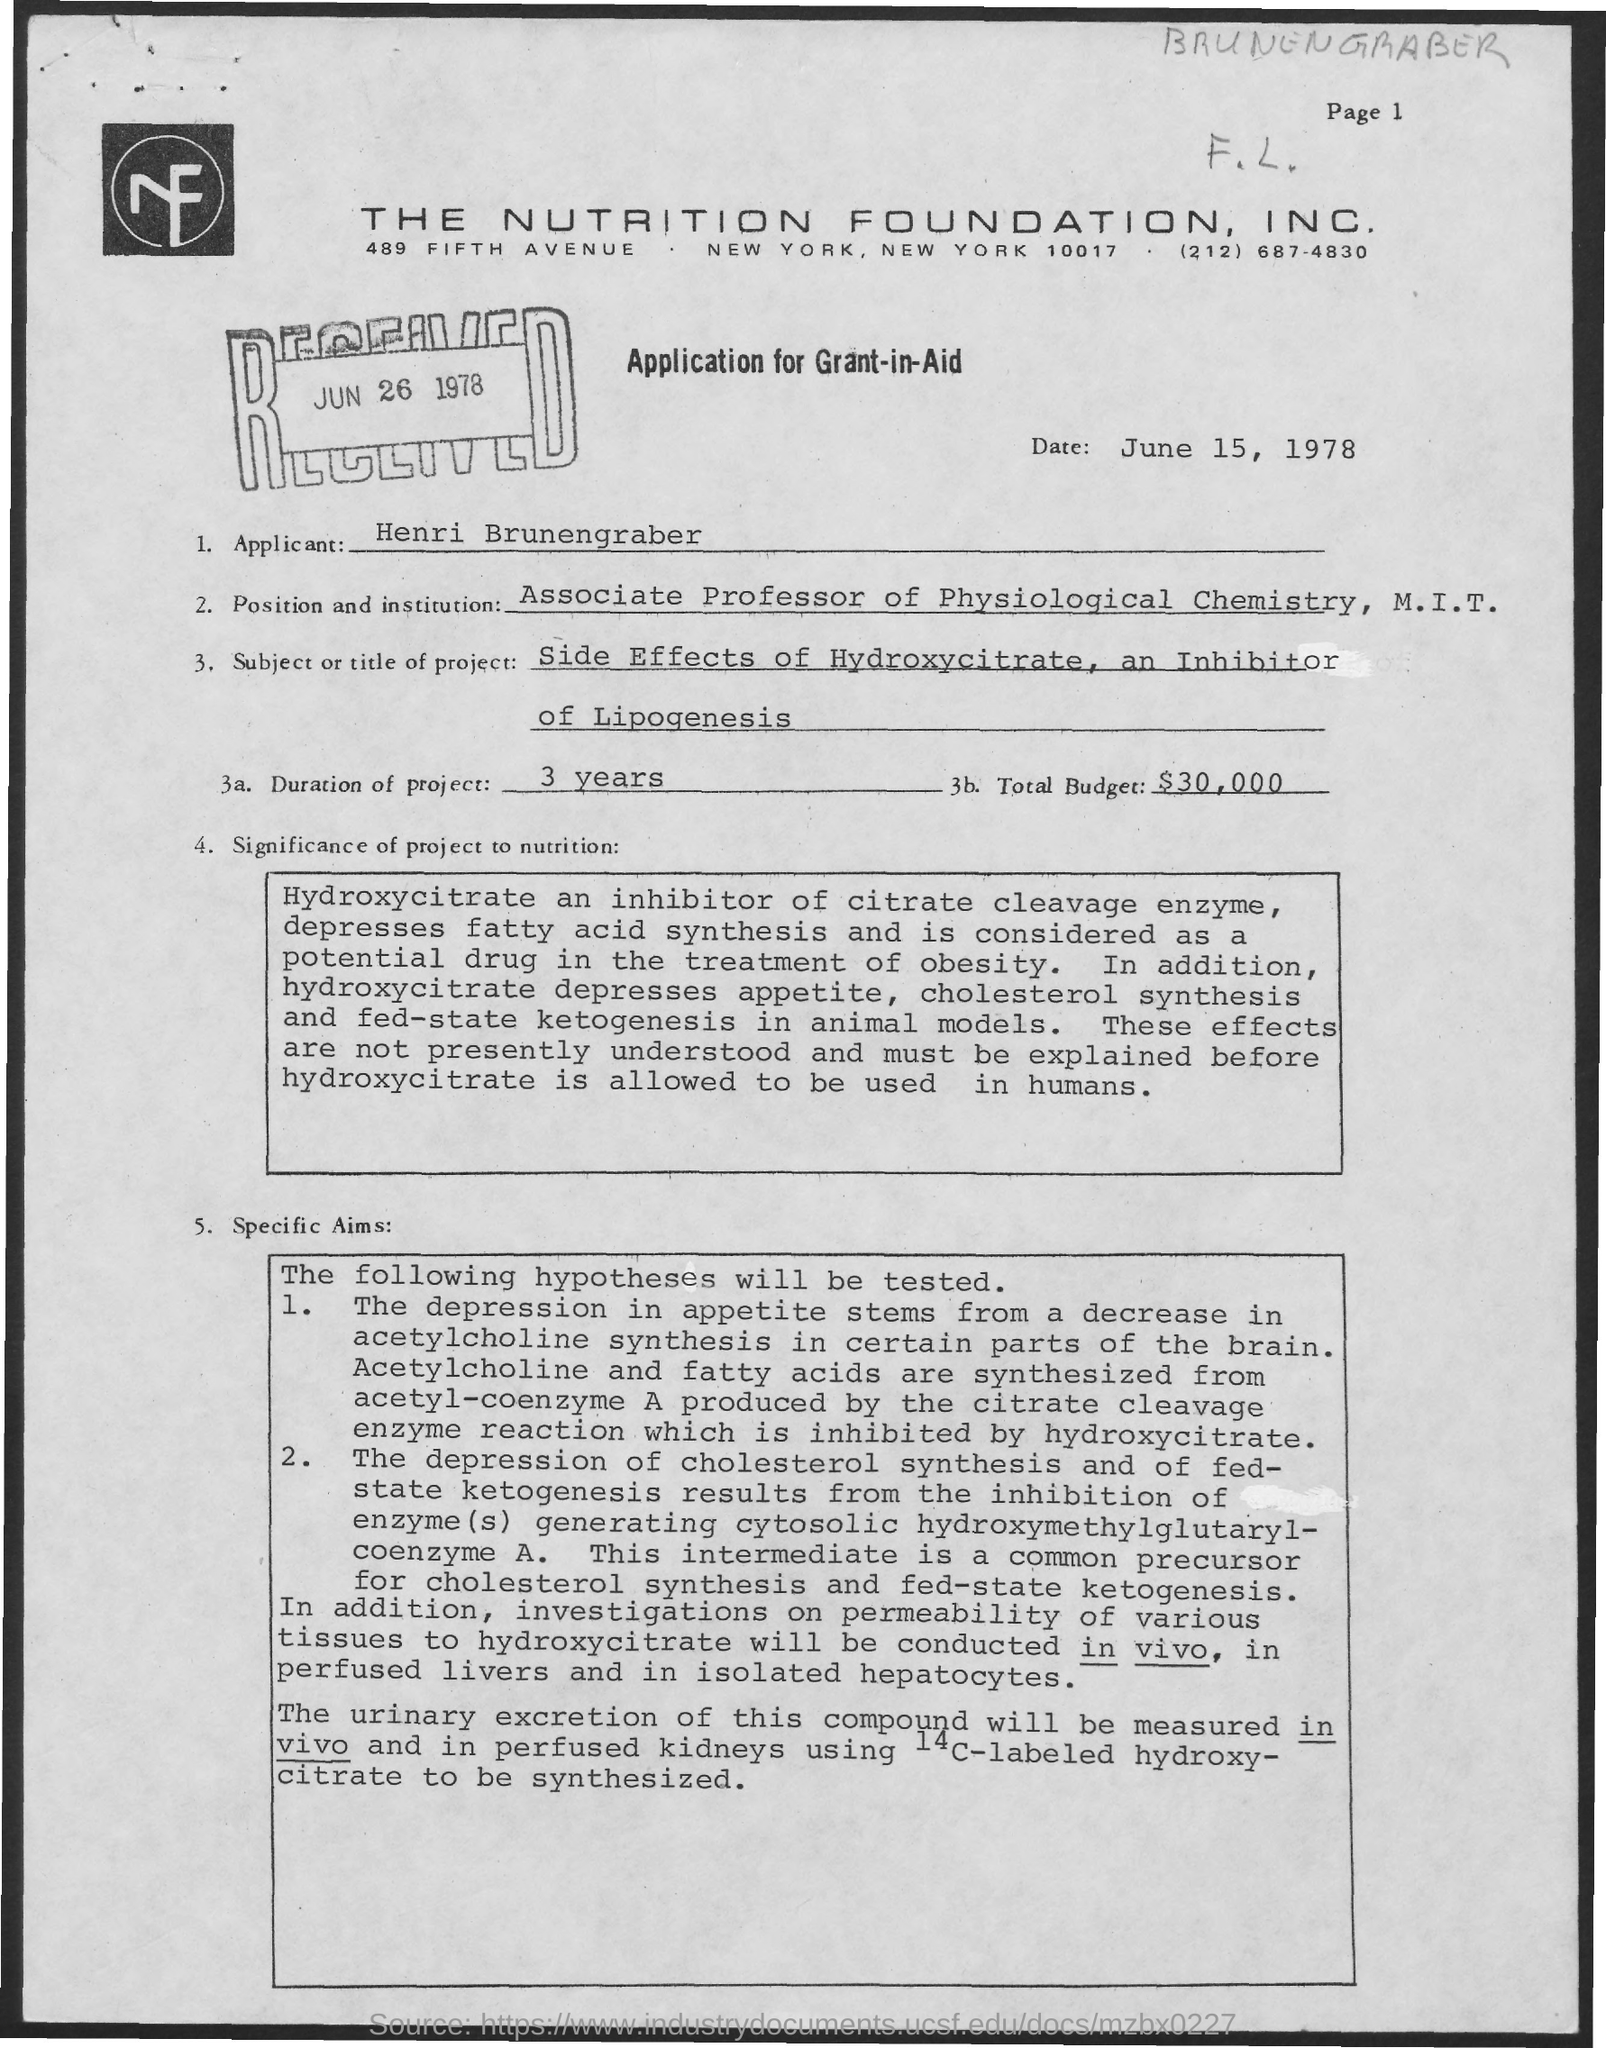Identify some key points in this picture. The letter was received on June 26, 1978. The duration of the project mentioned in the given letter is three months. The name of the applicant mentioned in the given letter is Henri Brunengraber. The total budget mentioned in the given letter is $30,000. The date mentioned in the given page is June 15, 1978. 